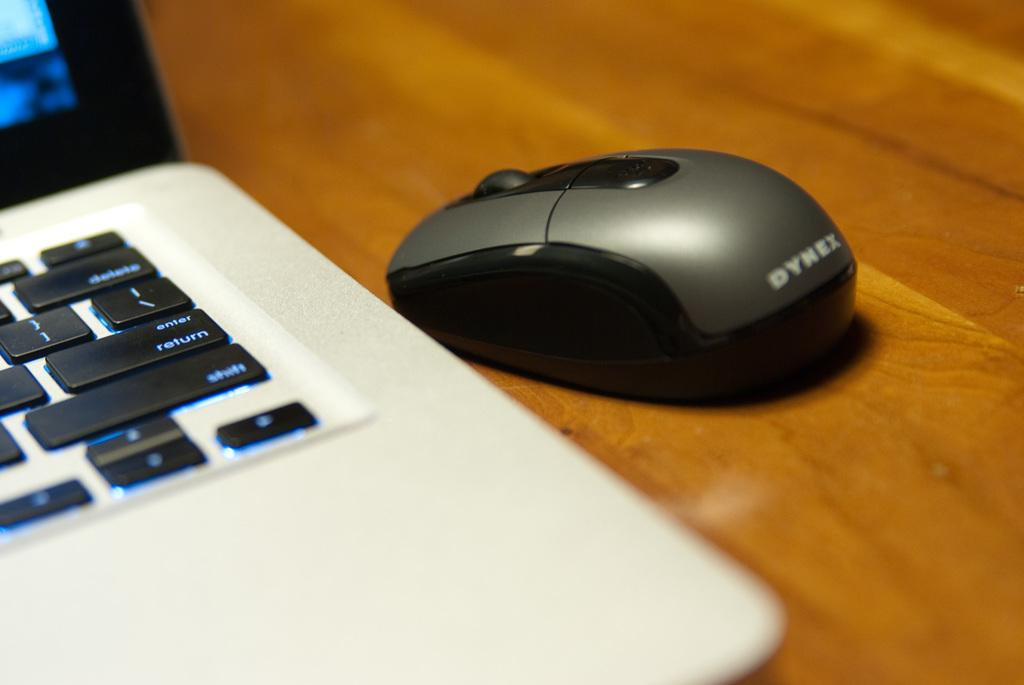<image>
Offer a succinct explanation of the picture presented. A Dynex computer mouse sets beside a laptop computer. 